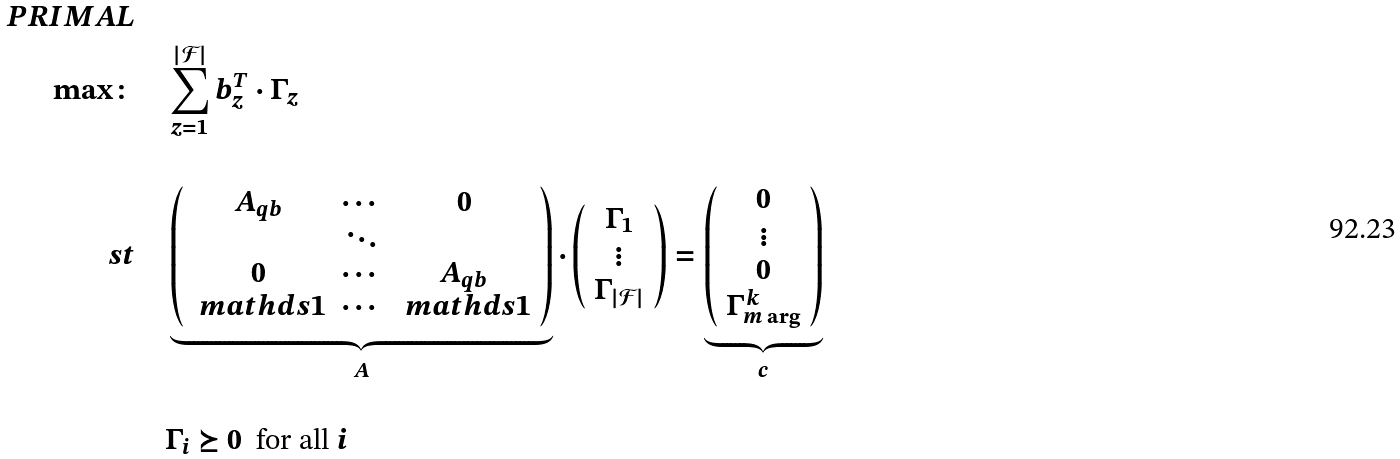<formula> <loc_0><loc_0><loc_500><loc_500>P R I M A L \\ \max \colon & \quad \sum _ { z = 1 } ^ { | \mathcal { F } | } b _ { z } ^ { T } \cdot \Gamma _ { z } \\ \\ \ s t & \quad \underbrace { \left ( \begin{array} { c c c } A _ { q b } & \cdots & 0 \\ & \ddots & \\ 0 & \cdots & A _ { q b } \\ \ m a t h d s { 1 } & \cdots & \ m a t h d s { 1 } \end{array} \right ) } _ { A } \cdot \left ( \begin{array} { c } \Gamma _ { 1 } \\ \vdots \\ \Gamma _ { | \mathcal { F } | } \end{array} \right ) = \underbrace { \left ( \begin{array} { c } 0 \\ \vdots \\ 0 \\ \Gamma _ { m \arg } ^ { k } \end{array} \right ) } _ { c } \\ \\ & \quad \Gamma _ { i } \succeq 0 \ \text { for all } i</formula> 